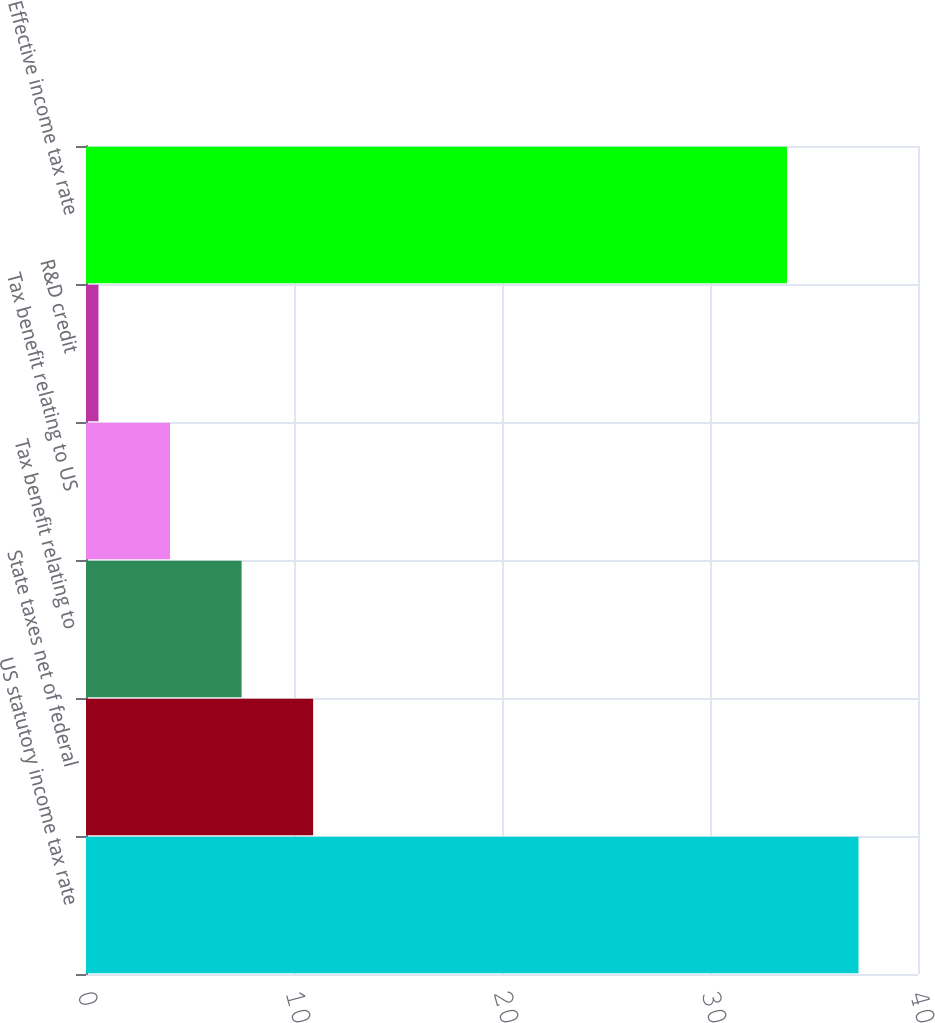Convert chart. <chart><loc_0><loc_0><loc_500><loc_500><bar_chart><fcel>US statutory income tax rate<fcel>State taxes net of federal<fcel>Tax benefit relating to<fcel>Tax benefit relating to US<fcel>R&D credit<fcel>Effective income tax rate<nl><fcel>37.14<fcel>10.92<fcel>7.48<fcel>4.04<fcel>0.6<fcel>33.7<nl></chart> 